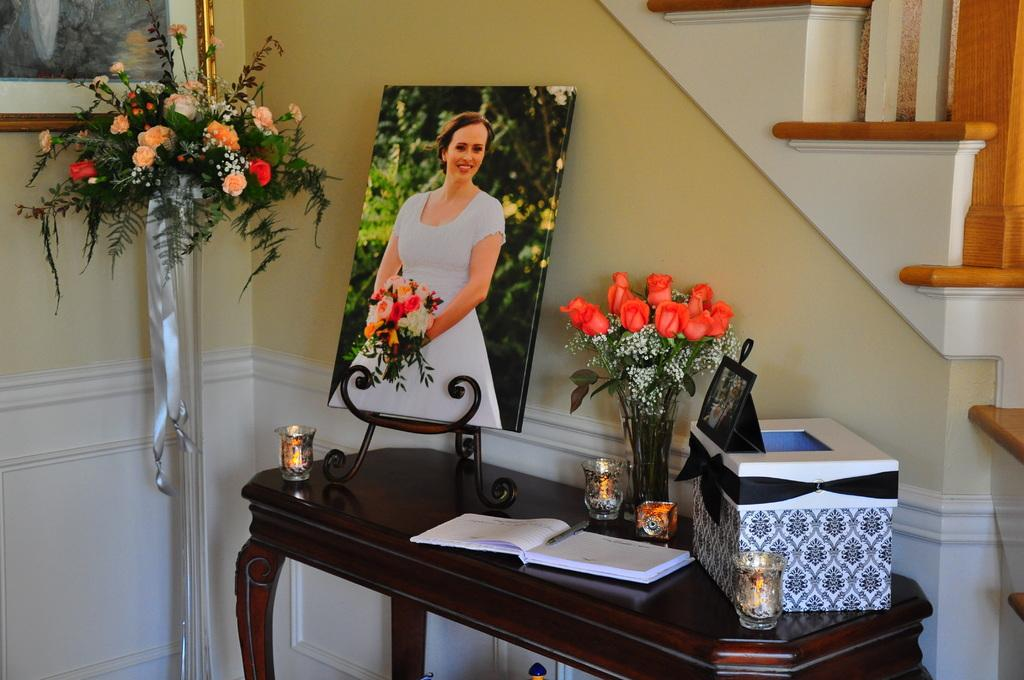What piece of furniture is present in the image? There is a table in the image. What items can be seen on the table? There is a book, a box, a flower pot, and a photo on the table. Can you describe the contents of the box? The facts provided do not give information about the contents of the box. What type of object is the photo? The facts provided do not specify the type of object the photo is. What actor is performing in the thunderstorm in the image? There is no actor or thunderstorm present in the image; it features a table with various objects on it. 